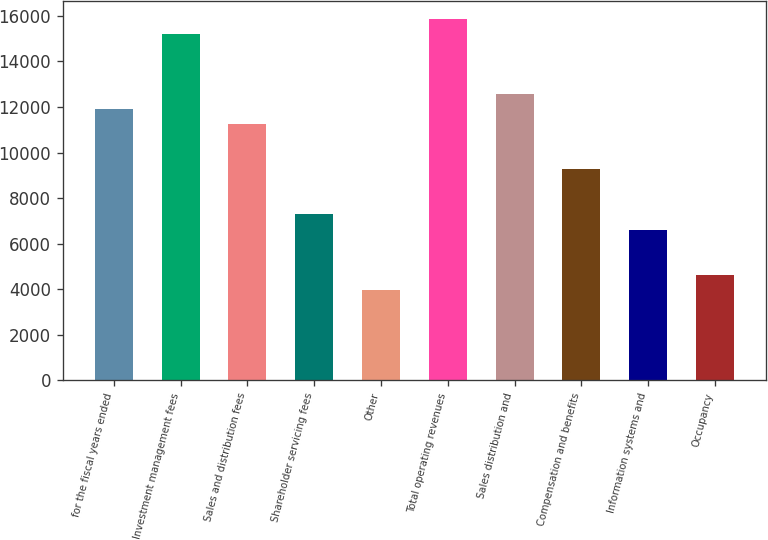<chart> <loc_0><loc_0><loc_500><loc_500><bar_chart><fcel>for the fiscal years ended<fcel>Investment management fees<fcel>Sales and distribution fees<fcel>Shareholder servicing fees<fcel>Other<fcel>Total operating revenues<fcel>Sales distribution and<fcel>Compensation and benefits<fcel>Information systems and<fcel>Occupancy<nl><fcel>11911.9<fcel>15220.5<fcel>11250.1<fcel>7279.75<fcel>3971.1<fcel>15882.2<fcel>12573.6<fcel>9264.94<fcel>6618.02<fcel>4632.83<nl></chart> 